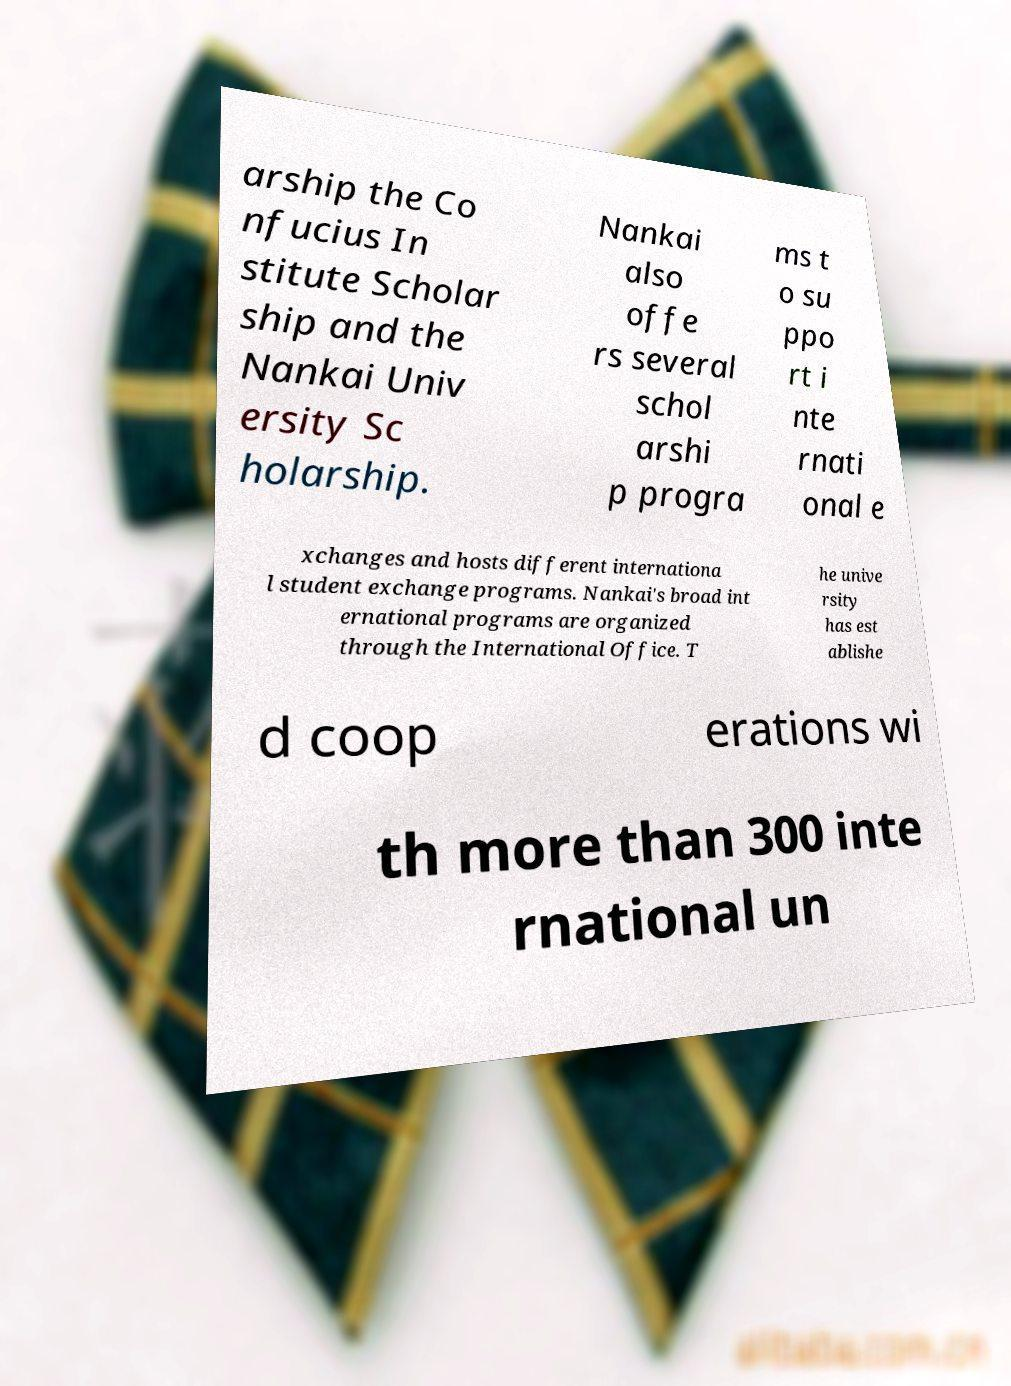For documentation purposes, I need the text within this image transcribed. Could you provide that? arship the Co nfucius In stitute Scholar ship and the Nankai Univ ersity Sc holarship. Nankai also offe rs several schol arshi p progra ms t o su ppo rt i nte rnati onal e xchanges and hosts different internationa l student exchange programs. Nankai's broad int ernational programs are organized through the International Office. T he unive rsity has est ablishe d coop erations wi th more than 300 inte rnational un 